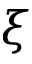<formula> <loc_0><loc_0><loc_500><loc_500>\xi</formula> 